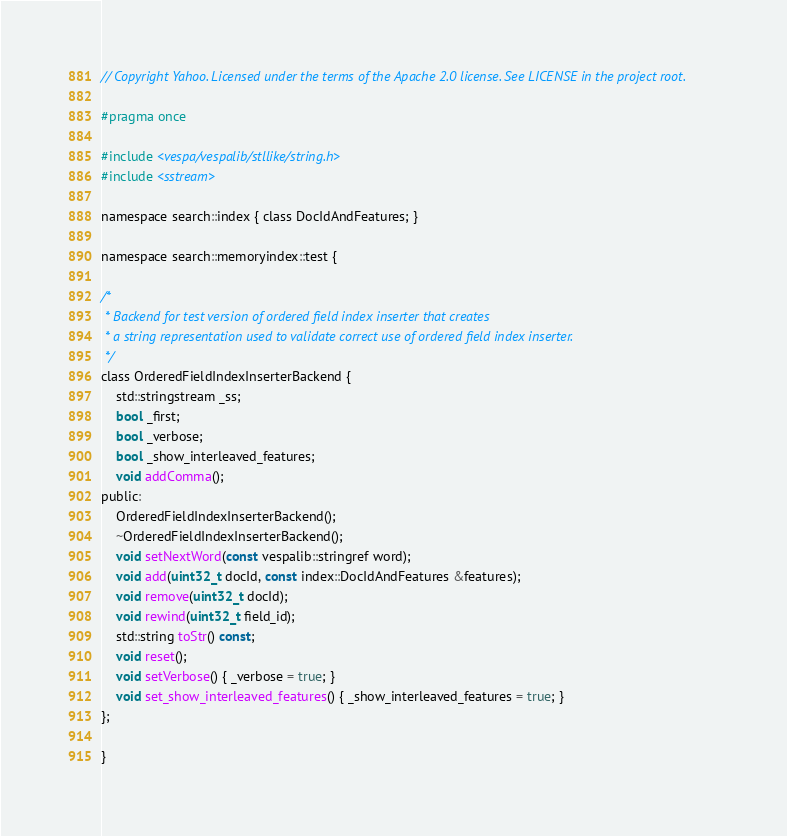<code> <loc_0><loc_0><loc_500><loc_500><_C_>// Copyright Yahoo. Licensed under the terms of the Apache 2.0 license. See LICENSE in the project root.

#pragma once

#include <vespa/vespalib/stllike/string.h>
#include <sstream>

namespace search::index { class DocIdAndFeatures; }

namespace search::memoryindex::test {

/*
 * Backend for test version of ordered field index inserter that creates
 * a string representation used to validate correct use of ordered field index inserter.
 */
class OrderedFieldIndexInserterBackend {
    std::stringstream _ss;
    bool _first;
    bool _verbose;
    bool _show_interleaved_features;
    void addComma();
public:
    OrderedFieldIndexInserterBackend();
    ~OrderedFieldIndexInserterBackend();
    void setNextWord(const vespalib::stringref word);
    void add(uint32_t docId, const index::DocIdAndFeatures &features);
    void remove(uint32_t docId);
    void rewind(uint32_t field_id);
    std::string toStr() const;
    void reset();
    void setVerbose() { _verbose = true; }
    void set_show_interleaved_features() { _show_interleaved_features = true; }
};

}
</code> 